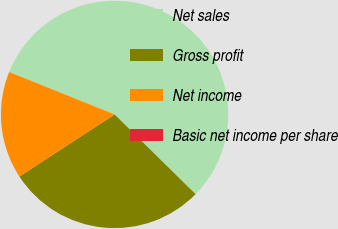Convert chart. <chart><loc_0><loc_0><loc_500><loc_500><pie_chart><fcel>Net sales<fcel>Gross profit<fcel>Net income<fcel>Basic net income per share<nl><fcel>56.29%<fcel>28.43%<fcel>15.28%<fcel>0.0%<nl></chart> 